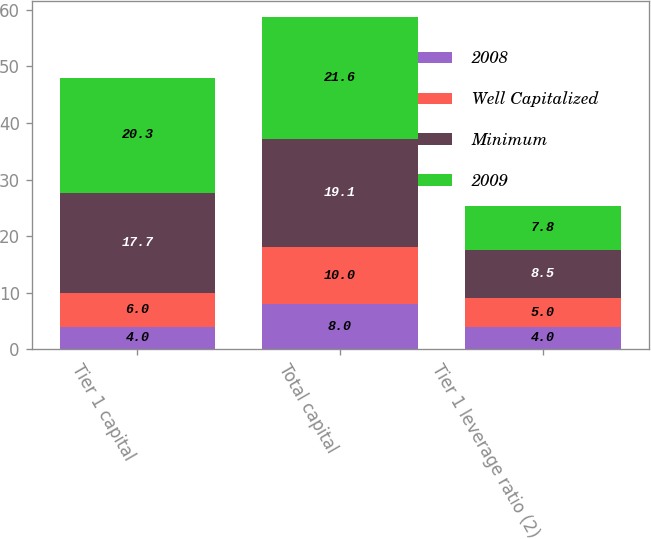Convert chart to OTSL. <chart><loc_0><loc_0><loc_500><loc_500><stacked_bar_chart><ecel><fcel>Tier 1 capital<fcel>Total capital<fcel>Tier 1 leverage ratio (2)<nl><fcel>2008<fcel>4<fcel>8<fcel>4<nl><fcel>Well Capitalized<fcel>6<fcel>10<fcel>5<nl><fcel>Minimum<fcel>17.7<fcel>19.1<fcel>8.5<nl><fcel>2009<fcel>20.3<fcel>21.6<fcel>7.8<nl></chart> 